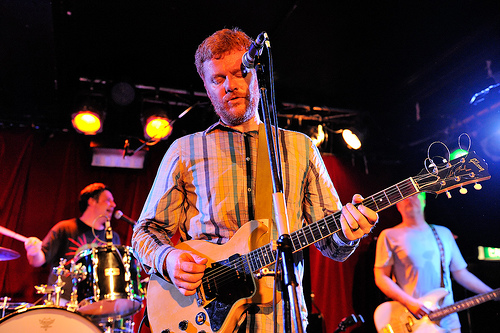<image>
Is there a guitar on the man? Yes. Looking at the image, I can see the guitar is positioned on top of the man, with the man providing support. 